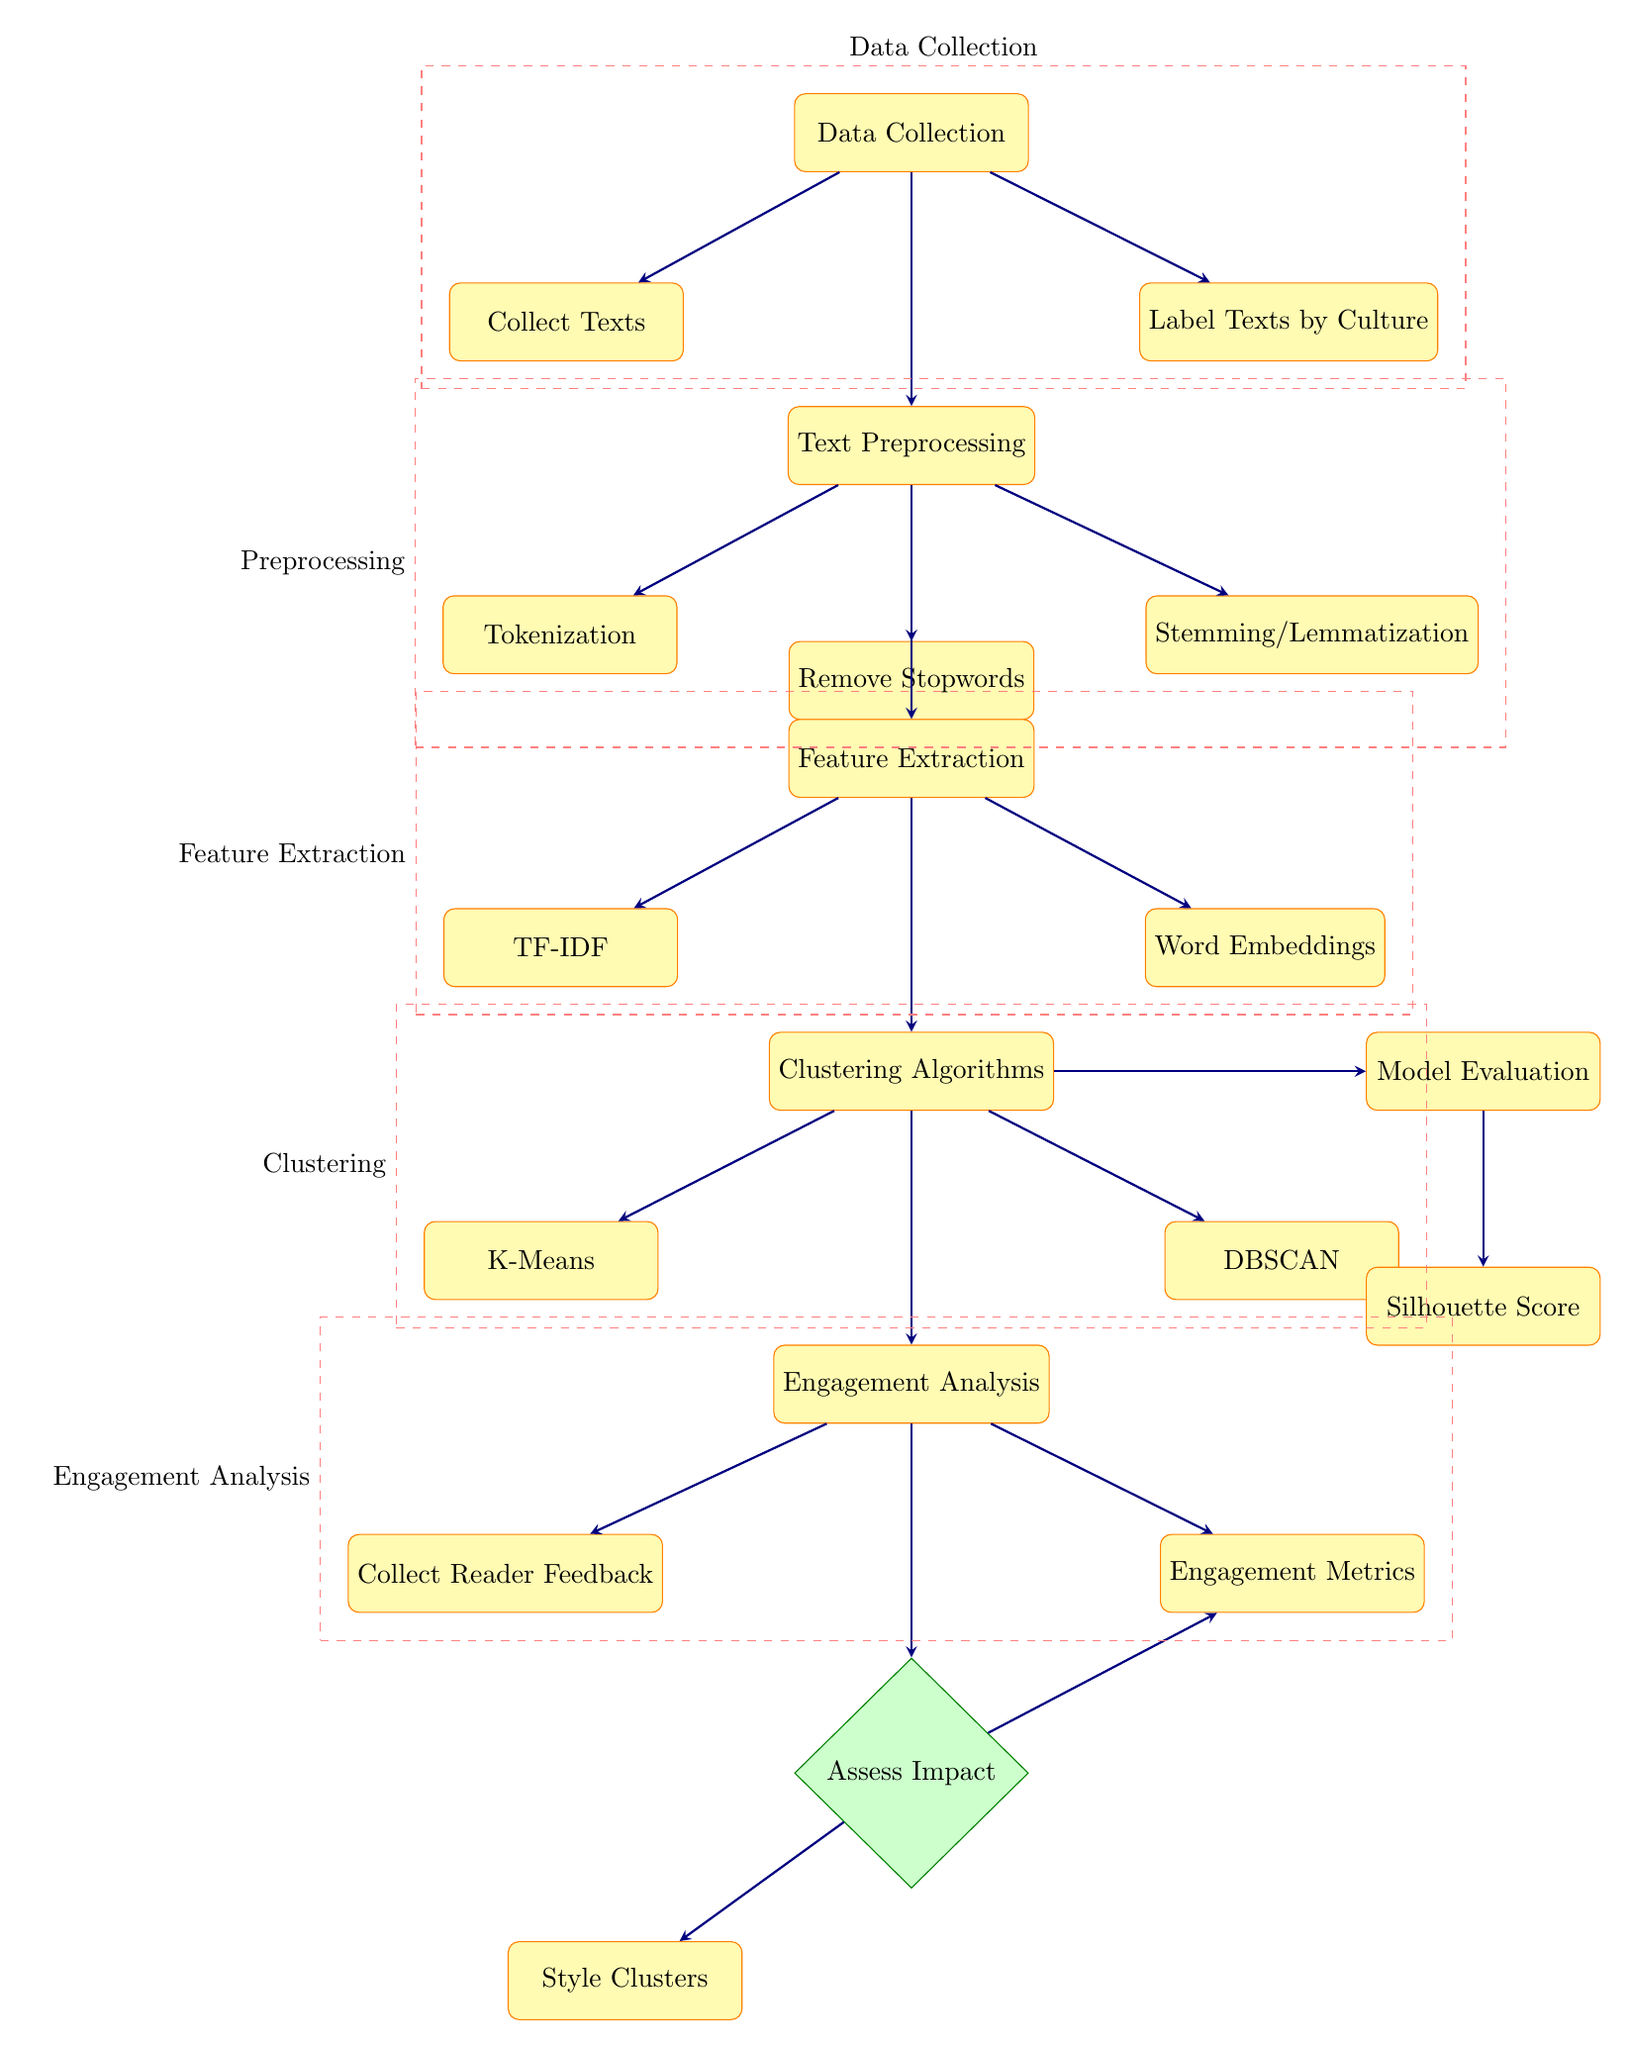What is the first step in the process? The first node in the diagram is "Data Collection," which is the initial step before any further processing occurs.
Answer: Data Collection How many processes are there in the Clustering section? In the Clustering section, there are three processes listed: "Clustering Algorithms," "K-Means," and "DBSCAN." Thus, there are two sub-processes under Clustering.
Answer: Two What kind of analysis is done after Collecting Reader Feedback? Following the collection of reader feedback, the next step in the diagram is "Engagement Metrics," which is part of the Engagement Analysis.
Answer: Engagement Metrics Which technique is used for Text Preprocessing? Under the Text Preprocessing category, the techniques listed are "Tokenization," "Remove Stopwords," and "Stemming/Lemmatization." Therefore, all are used for preprocessing.
Answer: Tokenization, Remove Stopwords, Stemming/Lemmatization What is assessed in the Impact Assessment stage? In the Impact Assessment stage, the decision point shows that the impact is assessed based on both "Style Clusters" and "Engagement Metrics," indicating these are the factors considered.
Answer: Style Clusters and Engagement Metrics Which algorithm comes after Feature Extraction in the process? After the "Feature Extraction" section, "Clustering Algorithms" is the next node to indicate the processes that utilize the extracted features.
Answer: Clustering Algorithms What type of diagram is this? The diagram illustrates a flowchart demonstrating processes related to Machine Learning, specifically focusing on clustering writing styles and their cultural impact.
Answer: Flowchart What is the output measure used in Model Evaluation? In the Model Evaluation section, the "Silhouette Score" is the output measure used to assess the clustering effectiveness.
Answer: Silhouette Score 